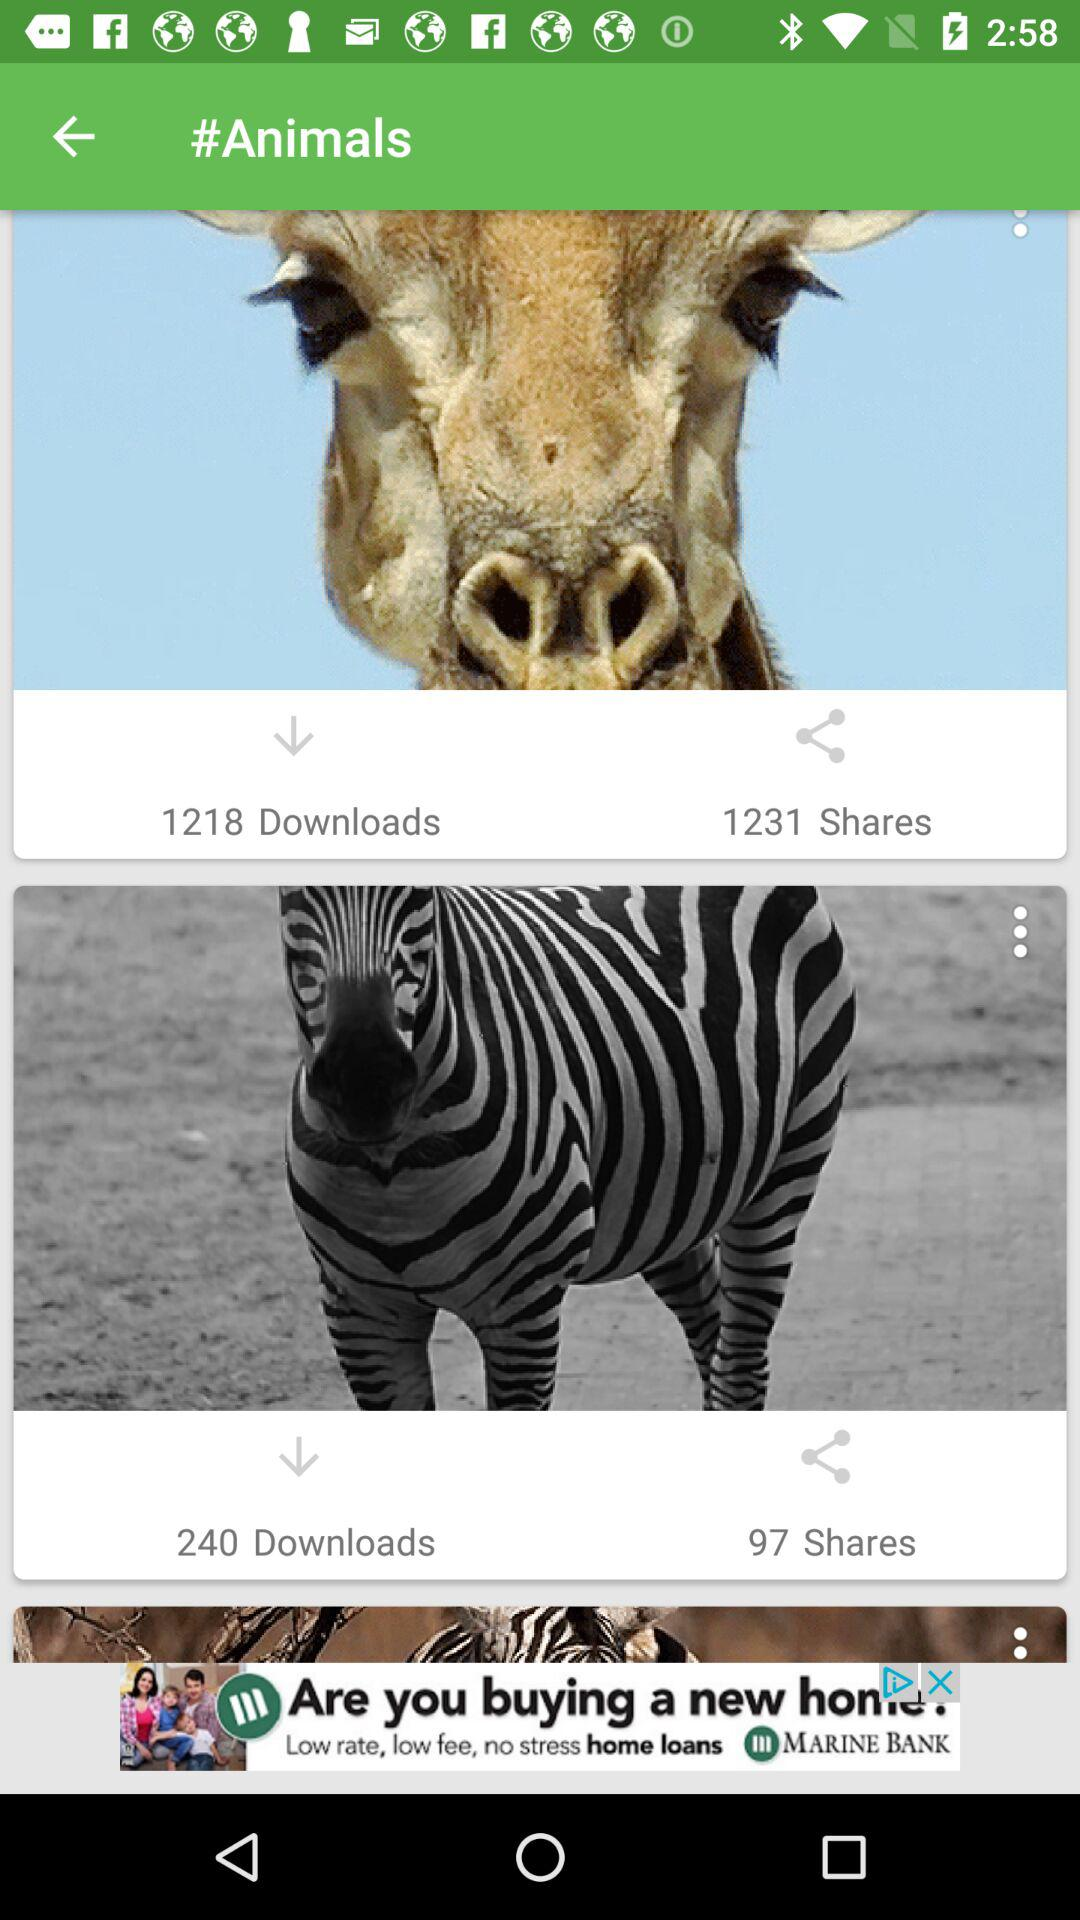How many more shares does the giraffe have than the zebra?
Answer the question using a single word or phrase. 1134 